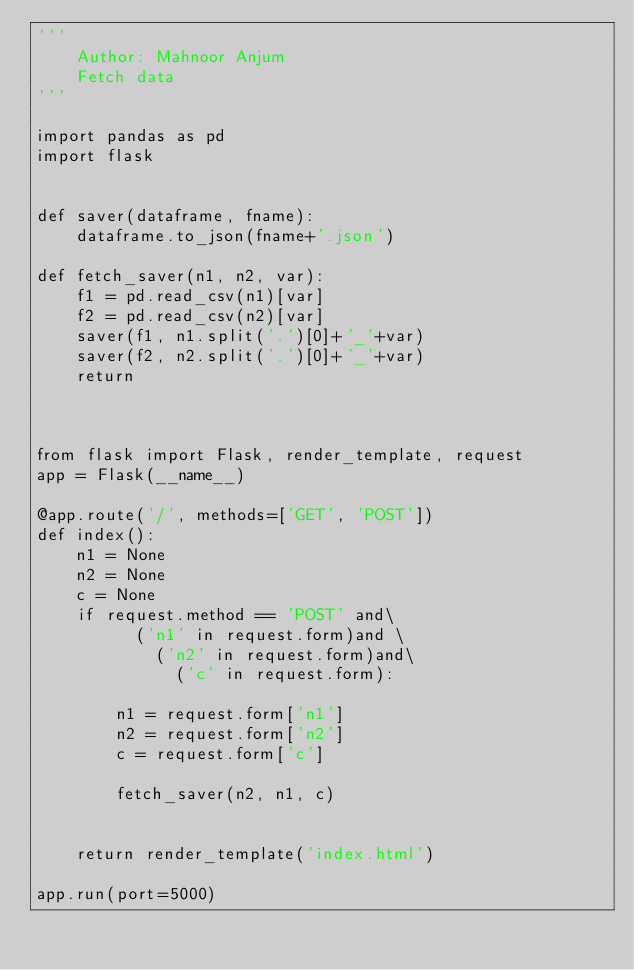Convert code to text. <code><loc_0><loc_0><loc_500><loc_500><_Python_>'''
    Author: Mahnoor Anjum
    Fetch data
'''

import pandas as pd 
import flask 


def saver(dataframe, fname):
    dataframe.to_json(fname+'.json')

def fetch_saver(n1, n2, var):
    f1 = pd.read_csv(n1)[var]
    f2 = pd.read_csv(n2)[var]
    saver(f1, n1.split('.')[0]+'_'+var)
    saver(f2, n2.split('.')[0]+'_'+var)
    return



from flask import Flask, render_template, request
app = Flask(__name__)

@app.route('/', methods=['GET', 'POST'])
def index():
    n1 = None
    n2 = None
    c = None
    if request.method == 'POST' and\
          ('n1' in request.form)and \
            ('n2' in request.form)and\
              ('c' in request.form):
                  
        n1 = request.form['n1']
        n2 = request.form['n2']
        c = request.form['c']

        fetch_saver(n2, n1, c)

       
    return render_template('index.html')

app.run(port=5000)

</code> 